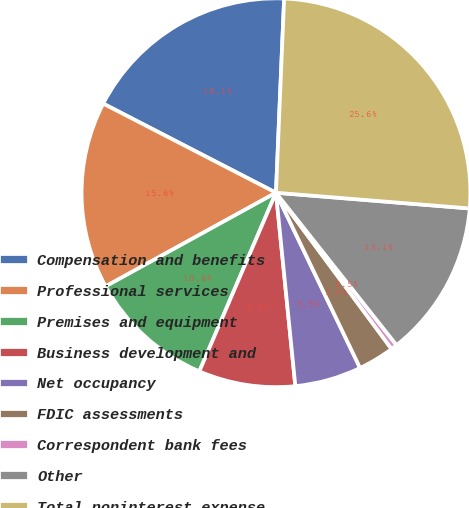Convert chart. <chart><loc_0><loc_0><loc_500><loc_500><pie_chart><fcel>Compensation and benefits<fcel>Professional services<fcel>Premises and equipment<fcel>Business development and<fcel>Net occupancy<fcel>FDIC assessments<fcel>Correspondent bank fees<fcel>Other<fcel>Total noninterest expense<nl><fcel>18.09%<fcel>15.58%<fcel>10.55%<fcel>8.04%<fcel>5.53%<fcel>3.02%<fcel>0.51%<fcel>13.06%<fcel>25.62%<nl></chart> 